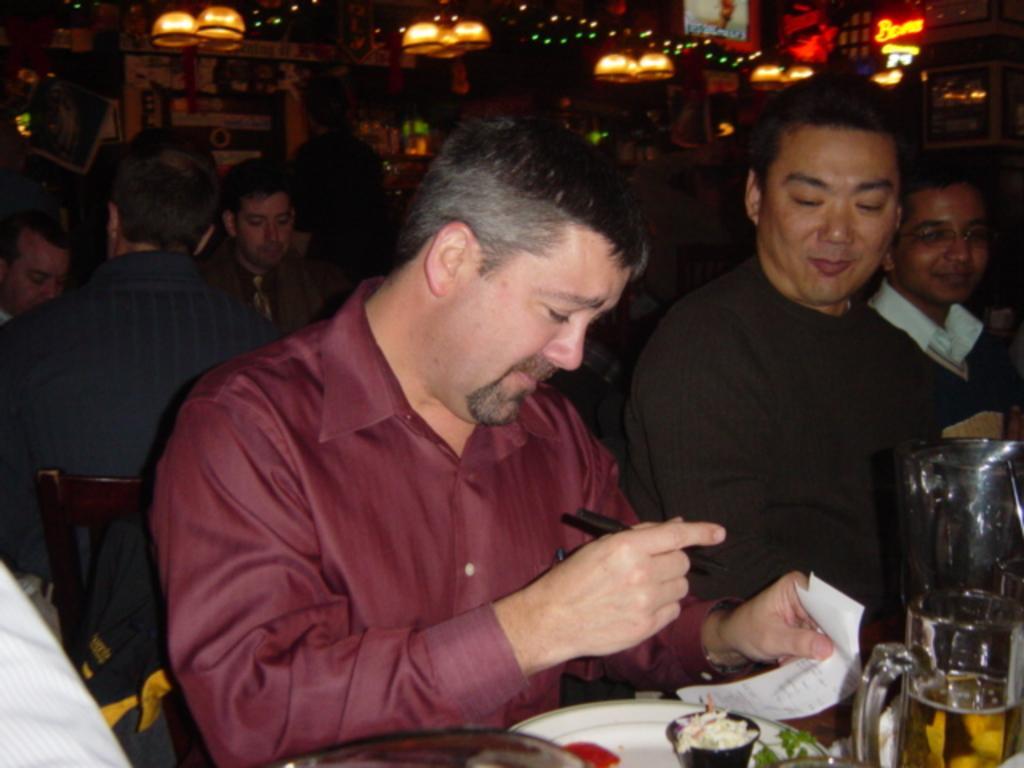How would you summarize this image in a sentence or two? In this image I can see group of people and I can see a plate and food item and a glass contain a drink at the bottom, at the top I can see lights. 